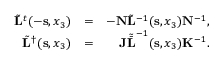<formula> <loc_0><loc_0><loc_500><loc_500>\begin{array} { r l r } { \tilde { L } ^ { t } ( - { s } , x _ { 3 } ) } & { = } & { - { N } \tilde { L } ^ { - 1 } ( { s } , x _ { 3 } ) { N } ^ { - 1 } , } \\ { \tilde { L } ^ { \dagger } ( { s } , x _ { 3 } ) } & { = } & { { J } { \tilde { \bar { L } } } ^ { - 1 } ( { s } , x _ { 3 } ) { K } ^ { - 1 } . } \end{array}</formula> 